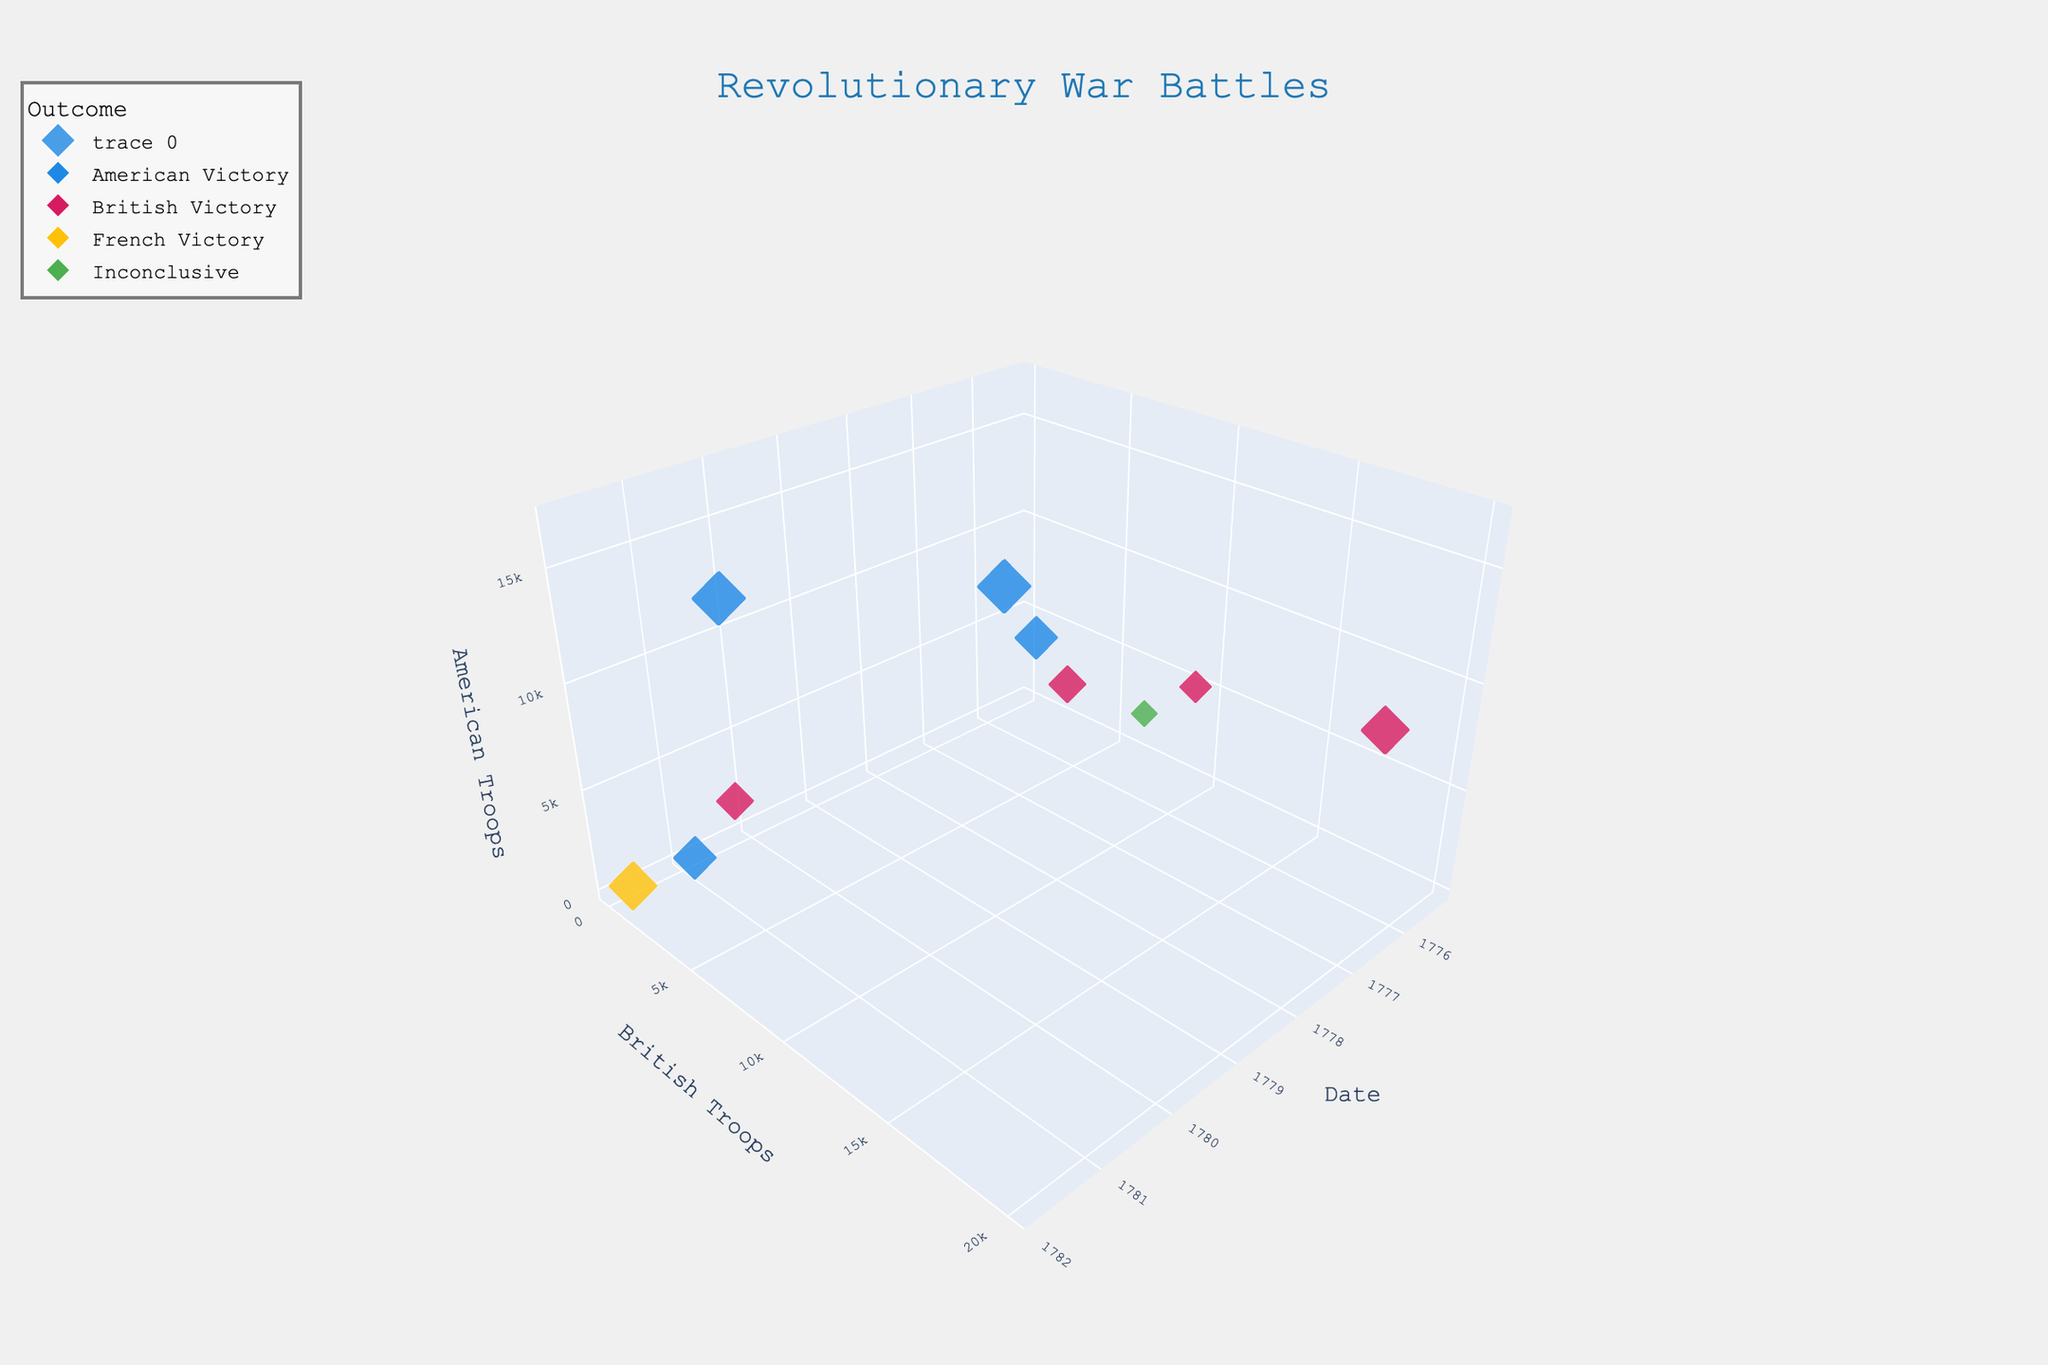What is the title of the chart? The title is displayed prominently at the top of the chart. It reads "Revolutionary War Battles", indicating the subject of the 3D bubble chart.
Answer: Revolutionary War Battles Which battle has the largest bubble size, and what does it represent? The largest bubble size in the chart is for the Battle of Saratoga. The size of the bubble represents the significance of the battle, which is 10, the highest value in the dataset.
Answer: Saratoga How many battles resulted in American victories? By observing the color legend and corresponding bubbles, count the blue-colored bubbles which signify American victories. There are four blue bubbles indicating four battles.
Answer: 4 Which battle had the fewest troops involved? The battle with the smallest y and z values on the chart has the fewest troops. The Battle of Chesapeake Bay had 19 British and 24 American troops, the smallest numbers.
Answer: Chesapeake Bay Compare the number of British and American troops in the Battle of Yorktown. Locate the bubble for the Battle of Yorktown. The hover text reveals it had 8000 British troops and 17000 American troops. Compare these numbers to note the difference.
Answer: 8000 British, 17000 American What was the outcome of the Battle of Long Island, and how significant was it? Locate the bubble for the Battle of Long Island. The hover text shows that the outcome was a British Victory. Its significance is 9.
Answer: British Victory, Significance 9 Which battle occurred first, and what was the outcome? By checking the positioning along the date axis, the earliest battle is Lexington and Concord. The hover text reveals the outcome was an American Victory.
Answer: Lexington and Concord, American Victory Compare the number of American troops in the Battle of Bunker Hill and the Battle of Monmouth. Locate the bubbles for both battles. The hover text shows 2400 American troops in Bunker Hill and 11000 in Monmouth.
Answer: Bunker Hill had 2400, Monmouth had 11000 How many battles had an inconclusive outcome? Check the color legend to identify the green bubbles representing inconclusive outcomes. There is one green bubble in the chart indicating one battle.
Answer: 1 What is the date of the Battle of Brandywine, and how many troops were involved on each side? Locate the bubble for the Battle of Brandywine. The hover text shows the date as 1777-09-11, with 15000 British troops and 11000 American troops.
Answer: 1777-09-11, 15000 British, 11000 American 